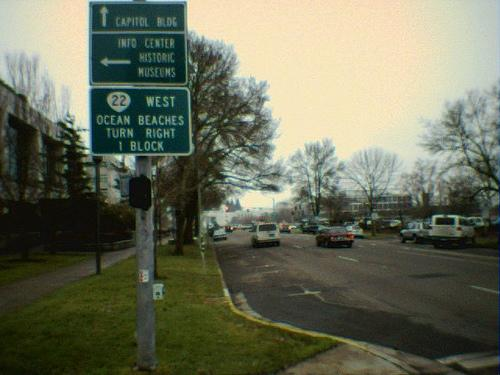What type of signs are these? street signs 